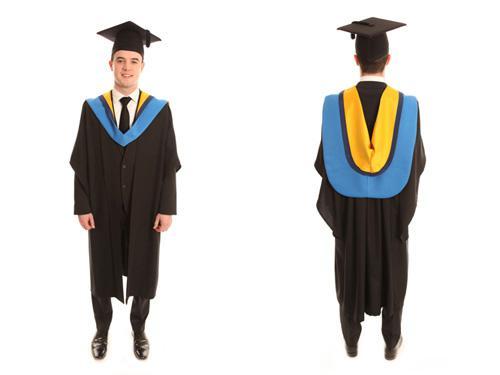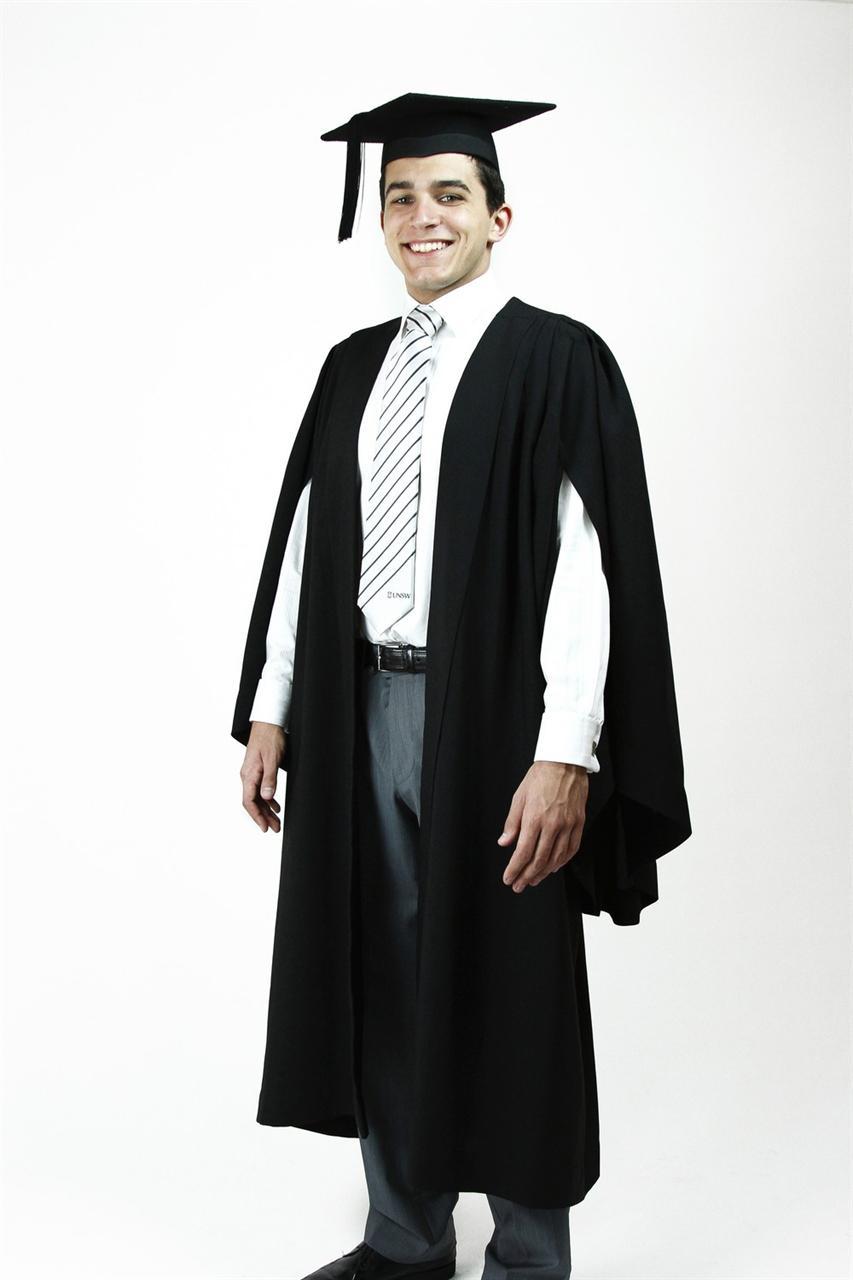The first image is the image on the left, the second image is the image on the right. Evaluate the accuracy of this statement regarding the images: "All caps and gowns in the images are modeled by actual people who are shown in full length, from head to toe.". Is it true? Answer yes or no. Yes. The first image is the image on the left, the second image is the image on the right. For the images displayed, is the sentence "Each image includes a backward-facing male modeling graduation attire." factually correct? Answer yes or no. No. 